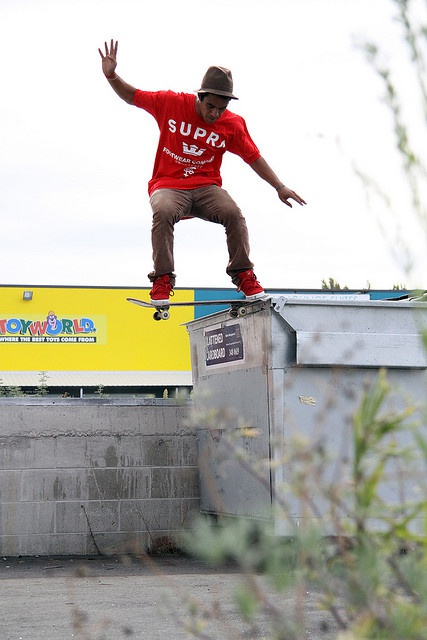Describe the objects in this image and their specific colors. I can see people in white, maroon, black, and brown tones and skateboard in white, black, gray, darkgray, and pink tones in this image. 